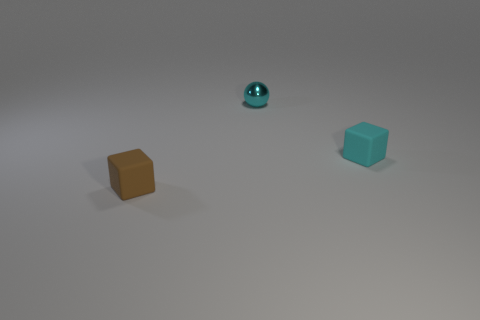There is another rubber thing that is the same size as the brown rubber object; what color is it?
Ensure brevity in your answer.  Cyan. What material is the thing to the right of the cyan ball?
Offer a very short reply. Rubber. Is the shape of the tiny matte object behind the small brown rubber object the same as the thing that is to the left of the cyan metal sphere?
Give a very brief answer. Yes. Are there an equal number of cyan cubes that are right of the cyan matte object and metal balls?
Make the answer very short. No. What number of tiny things have the same material as the tiny brown cube?
Give a very brief answer. 1. The small thing that is made of the same material as the cyan cube is what color?
Offer a very short reply. Brown. The small metallic thing has what shape?
Your answer should be very brief. Sphere. How many blocks are the same color as the tiny metallic ball?
Offer a terse response. 1. What color is the other matte thing that is the same shape as the small brown matte object?
Provide a short and direct response. Cyan. How many small cyan spheres are to the right of the tiny rubber block right of the metal thing?
Give a very brief answer. 0. 